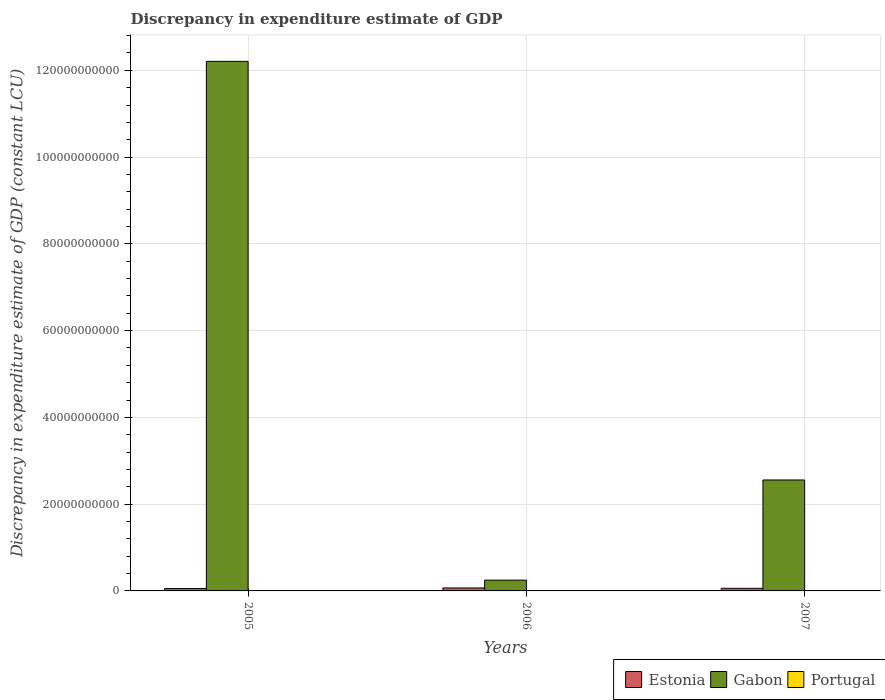Are the number of bars per tick equal to the number of legend labels?
Your answer should be very brief. No. Are the number of bars on each tick of the X-axis equal?
Offer a terse response. Yes. How many bars are there on the 1st tick from the right?
Your answer should be very brief. 2. What is the label of the 2nd group of bars from the left?
Your response must be concise. 2006. In how many cases, is the number of bars for a given year not equal to the number of legend labels?
Your answer should be very brief. 3. Across all years, what is the maximum discrepancy in expenditure estimate of GDP in Estonia?
Your response must be concise. 6.85e+08. Across all years, what is the minimum discrepancy in expenditure estimate of GDP in Gabon?
Your answer should be compact. 2.49e+09. In which year was the discrepancy in expenditure estimate of GDP in Gabon maximum?
Offer a very short reply. 2005. What is the total discrepancy in expenditure estimate of GDP in Estonia in the graph?
Offer a terse response. 1.84e+09. What is the difference between the discrepancy in expenditure estimate of GDP in Estonia in 2005 and that in 2006?
Provide a short and direct response. -1.36e+08. What is the difference between the discrepancy in expenditure estimate of GDP in Gabon in 2007 and the discrepancy in expenditure estimate of GDP in Estonia in 2005?
Your response must be concise. 2.50e+1. In the year 2007, what is the difference between the discrepancy in expenditure estimate of GDP in Estonia and discrepancy in expenditure estimate of GDP in Gabon?
Provide a succinct answer. -2.50e+1. Is the discrepancy in expenditure estimate of GDP in Estonia in 2006 less than that in 2007?
Your answer should be compact. No. What is the difference between the highest and the second highest discrepancy in expenditure estimate of GDP in Estonia?
Ensure brevity in your answer.  8.09e+07. What is the difference between the highest and the lowest discrepancy in expenditure estimate of GDP in Estonia?
Your answer should be compact. 1.36e+08. In how many years, is the discrepancy in expenditure estimate of GDP in Gabon greater than the average discrepancy in expenditure estimate of GDP in Gabon taken over all years?
Offer a terse response. 1. Is the sum of the discrepancy in expenditure estimate of GDP in Gabon in 2006 and 2007 greater than the maximum discrepancy in expenditure estimate of GDP in Estonia across all years?
Keep it short and to the point. Yes. How many bars are there?
Provide a succinct answer. 6. Are all the bars in the graph horizontal?
Give a very brief answer. No. Does the graph contain grids?
Your answer should be very brief. Yes. Where does the legend appear in the graph?
Provide a short and direct response. Bottom right. How many legend labels are there?
Provide a succinct answer. 3. What is the title of the graph?
Your answer should be very brief. Discrepancy in expenditure estimate of GDP. Does "Ecuador" appear as one of the legend labels in the graph?
Your answer should be very brief. No. What is the label or title of the Y-axis?
Provide a short and direct response. Discrepancy in expenditure estimate of GDP (constant LCU). What is the Discrepancy in expenditure estimate of GDP (constant LCU) of Estonia in 2005?
Provide a succinct answer. 5.50e+08. What is the Discrepancy in expenditure estimate of GDP (constant LCU) in Gabon in 2005?
Your answer should be compact. 1.22e+11. What is the Discrepancy in expenditure estimate of GDP (constant LCU) in Estonia in 2006?
Your response must be concise. 6.85e+08. What is the Discrepancy in expenditure estimate of GDP (constant LCU) in Gabon in 2006?
Give a very brief answer. 2.49e+09. What is the Discrepancy in expenditure estimate of GDP (constant LCU) in Portugal in 2006?
Your answer should be compact. 0. What is the Discrepancy in expenditure estimate of GDP (constant LCU) in Estonia in 2007?
Keep it short and to the point. 6.04e+08. What is the Discrepancy in expenditure estimate of GDP (constant LCU) in Gabon in 2007?
Provide a succinct answer. 2.56e+1. Across all years, what is the maximum Discrepancy in expenditure estimate of GDP (constant LCU) in Estonia?
Make the answer very short. 6.85e+08. Across all years, what is the maximum Discrepancy in expenditure estimate of GDP (constant LCU) in Gabon?
Your answer should be very brief. 1.22e+11. Across all years, what is the minimum Discrepancy in expenditure estimate of GDP (constant LCU) in Estonia?
Provide a succinct answer. 5.50e+08. Across all years, what is the minimum Discrepancy in expenditure estimate of GDP (constant LCU) in Gabon?
Ensure brevity in your answer.  2.49e+09. What is the total Discrepancy in expenditure estimate of GDP (constant LCU) of Estonia in the graph?
Provide a succinct answer. 1.84e+09. What is the total Discrepancy in expenditure estimate of GDP (constant LCU) in Gabon in the graph?
Make the answer very short. 1.50e+11. What is the total Discrepancy in expenditure estimate of GDP (constant LCU) in Portugal in the graph?
Offer a terse response. 0. What is the difference between the Discrepancy in expenditure estimate of GDP (constant LCU) in Estonia in 2005 and that in 2006?
Your answer should be compact. -1.36e+08. What is the difference between the Discrepancy in expenditure estimate of GDP (constant LCU) of Gabon in 2005 and that in 2006?
Your response must be concise. 1.20e+11. What is the difference between the Discrepancy in expenditure estimate of GDP (constant LCU) in Estonia in 2005 and that in 2007?
Offer a very short reply. -5.46e+07. What is the difference between the Discrepancy in expenditure estimate of GDP (constant LCU) in Gabon in 2005 and that in 2007?
Provide a short and direct response. 9.65e+1. What is the difference between the Discrepancy in expenditure estimate of GDP (constant LCU) of Estonia in 2006 and that in 2007?
Your answer should be very brief. 8.09e+07. What is the difference between the Discrepancy in expenditure estimate of GDP (constant LCU) of Gabon in 2006 and that in 2007?
Provide a succinct answer. -2.31e+1. What is the difference between the Discrepancy in expenditure estimate of GDP (constant LCU) of Estonia in 2005 and the Discrepancy in expenditure estimate of GDP (constant LCU) of Gabon in 2006?
Your response must be concise. -1.94e+09. What is the difference between the Discrepancy in expenditure estimate of GDP (constant LCU) of Estonia in 2005 and the Discrepancy in expenditure estimate of GDP (constant LCU) of Gabon in 2007?
Make the answer very short. -2.50e+1. What is the difference between the Discrepancy in expenditure estimate of GDP (constant LCU) in Estonia in 2006 and the Discrepancy in expenditure estimate of GDP (constant LCU) in Gabon in 2007?
Keep it short and to the point. -2.49e+1. What is the average Discrepancy in expenditure estimate of GDP (constant LCU) of Estonia per year?
Provide a succinct answer. 6.13e+08. What is the average Discrepancy in expenditure estimate of GDP (constant LCU) in Gabon per year?
Your answer should be very brief. 5.00e+1. In the year 2005, what is the difference between the Discrepancy in expenditure estimate of GDP (constant LCU) in Estonia and Discrepancy in expenditure estimate of GDP (constant LCU) in Gabon?
Ensure brevity in your answer.  -1.22e+11. In the year 2006, what is the difference between the Discrepancy in expenditure estimate of GDP (constant LCU) of Estonia and Discrepancy in expenditure estimate of GDP (constant LCU) of Gabon?
Your answer should be very brief. -1.80e+09. In the year 2007, what is the difference between the Discrepancy in expenditure estimate of GDP (constant LCU) in Estonia and Discrepancy in expenditure estimate of GDP (constant LCU) in Gabon?
Offer a terse response. -2.50e+1. What is the ratio of the Discrepancy in expenditure estimate of GDP (constant LCU) of Estonia in 2005 to that in 2006?
Your response must be concise. 0.8. What is the ratio of the Discrepancy in expenditure estimate of GDP (constant LCU) of Gabon in 2005 to that in 2006?
Provide a succinct answer. 49.06. What is the ratio of the Discrepancy in expenditure estimate of GDP (constant LCU) of Estonia in 2005 to that in 2007?
Provide a short and direct response. 0.91. What is the ratio of the Discrepancy in expenditure estimate of GDP (constant LCU) of Gabon in 2005 to that in 2007?
Give a very brief answer. 4.77. What is the ratio of the Discrepancy in expenditure estimate of GDP (constant LCU) of Estonia in 2006 to that in 2007?
Keep it short and to the point. 1.13. What is the ratio of the Discrepancy in expenditure estimate of GDP (constant LCU) of Gabon in 2006 to that in 2007?
Offer a very short reply. 0.1. What is the difference between the highest and the second highest Discrepancy in expenditure estimate of GDP (constant LCU) in Estonia?
Your answer should be very brief. 8.09e+07. What is the difference between the highest and the second highest Discrepancy in expenditure estimate of GDP (constant LCU) in Gabon?
Ensure brevity in your answer.  9.65e+1. What is the difference between the highest and the lowest Discrepancy in expenditure estimate of GDP (constant LCU) of Estonia?
Ensure brevity in your answer.  1.36e+08. What is the difference between the highest and the lowest Discrepancy in expenditure estimate of GDP (constant LCU) in Gabon?
Offer a very short reply. 1.20e+11. 